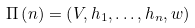<formula> <loc_0><loc_0><loc_500><loc_500>\Pi \left ( n \right ) = \left ( V , h _ { 1 } , \dots , h _ { n } , w \right )</formula> 